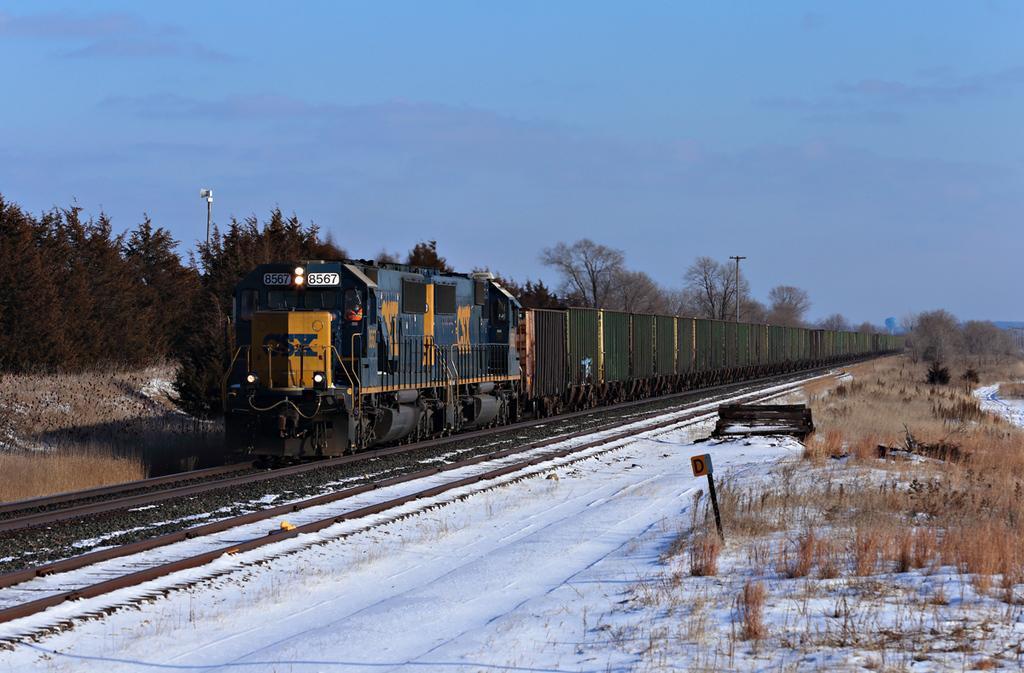Can you describe this image briefly? This image consists of a train. At the bottom, there are tracks covered with the snow. On the left and right, there are trees and we can see the dried grass on the ground. At the top, there is sky. 